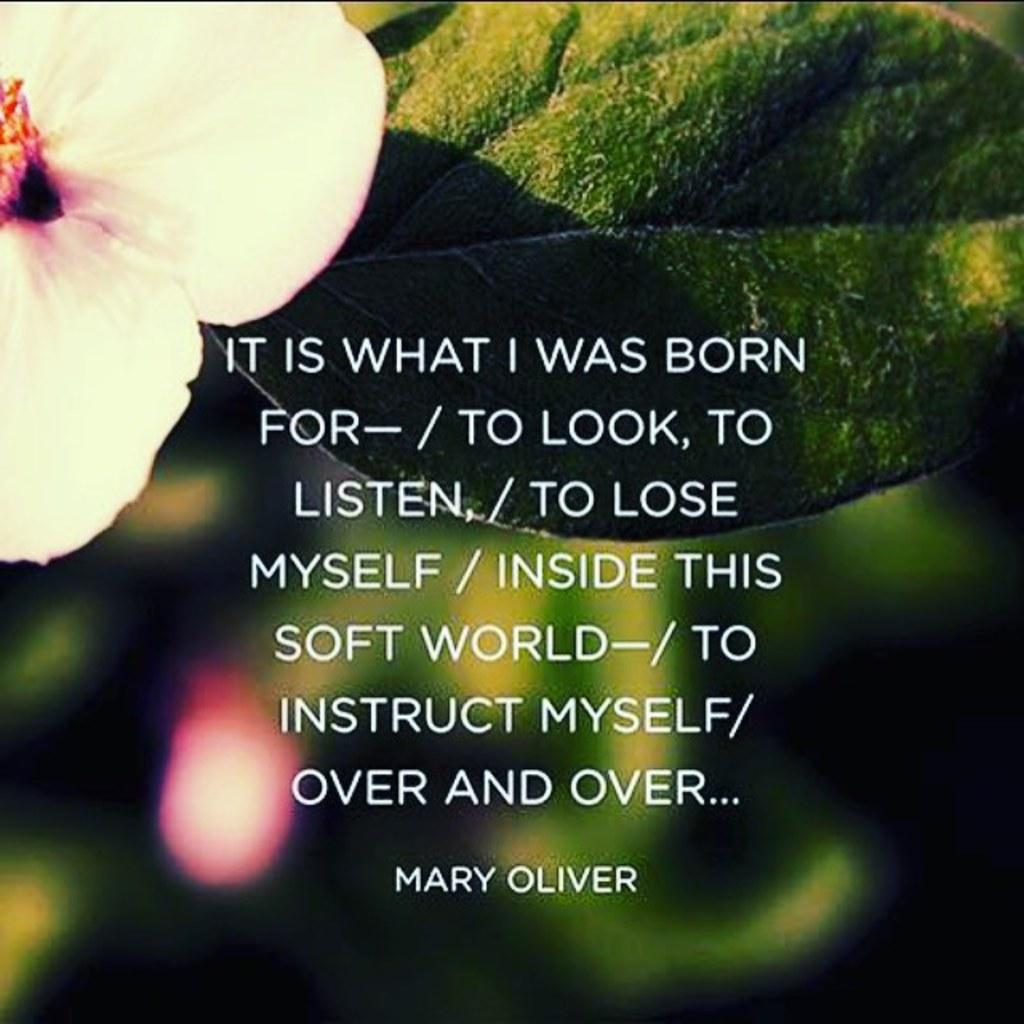What type of plant is visible in the image? There is a flower and a green leaf in the image. What else can be seen in the image besides the plant? There is writing in the image. How would you describe the quality of the background in the image? The background of the image is blurry. How does the boy in the image contribute to the comfort of the flower? There is no boy present in the image, so it is not possible to answer that question. 